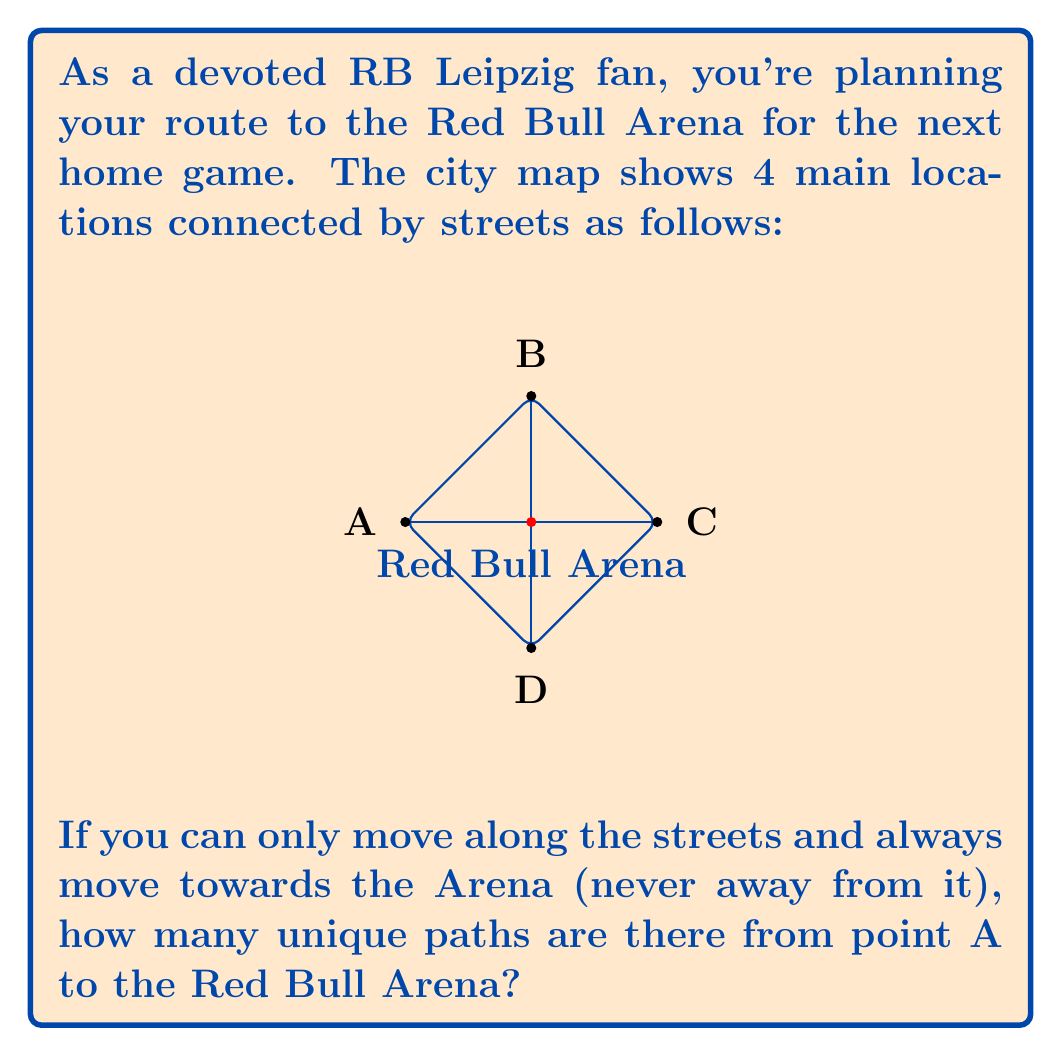Can you answer this question? Let's approach this step-by-step:

1) First, we need to recognize that this problem is equivalent to finding the number of paths from A to the Arena on a grid.

2) We can see that to reach the Arena from A, we need to move 2 steps right and 1 step up in any order.

3) This is a classic combination problem. We need to choose which 1 out of the 3 total steps will be the upward step.

4) The formula for this combination is:

   $$\binom{3}{1} = \frac{3!}{1!(3-1)!} = \frac{3!}{1!2!}$$

5) Let's calculate this:
   $$\frac{3 * 2 * 1}{(1) * (2 * 1)} = \frac{6}{2} = 3$$

6) We can verify this by listing all possible paths:
   - Right, Right, Up
   - Right, Up, Right
   - Up, Right, Right

Therefore, there are 3 unique paths from point A to the Red Bull Arena.
Answer: 3 